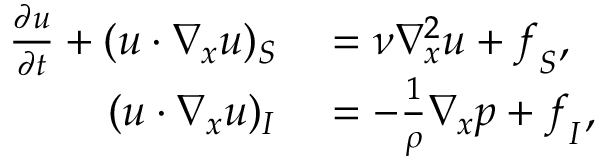Convert formula to latex. <formula><loc_0><loc_0><loc_500><loc_500>\begin{array} { r l } { \frac { \partial u } { \partial t } + ( u \cdot \nabla _ { x } u ) _ { S } } & = \nu \nabla _ { x } ^ { 2 } u + f _ { S } , } \\ { ( u \cdot \nabla _ { x } u ) _ { I } } & = - \frac { 1 } { \rho } \nabla _ { x } p + f _ { I } , } \end{array}</formula> 